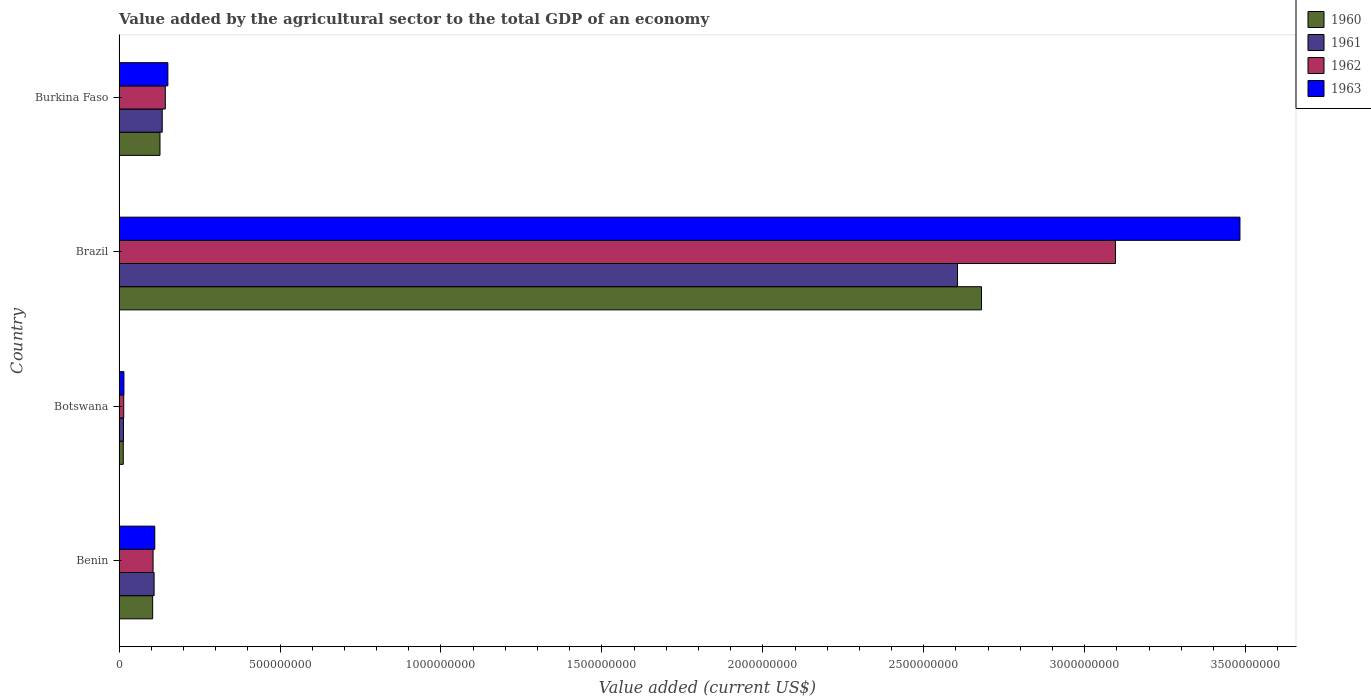How many groups of bars are there?
Your answer should be compact. 4. Are the number of bars per tick equal to the number of legend labels?
Provide a succinct answer. Yes. Are the number of bars on each tick of the Y-axis equal?
Your answer should be compact. Yes. What is the label of the 3rd group of bars from the top?
Your answer should be very brief. Botswana. What is the value added by the agricultural sector to the total GDP in 1960 in Burkina Faso?
Make the answer very short. 1.27e+08. Across all countries, what is the maximum value added by the agricultural sector to the total GDP in 1962?
Provide a succinct answer. 3.10e+09. Across all countries, what is the minimum value added by the agricultural sector to the total GDP in 1960?
Your answer should be compact. 1.31e+07. In which country was the value added by the agricultural sector to the total GDP in 1962 maximum?
Provide a succinct answer. Brazil. In which country was the value added by the agricultural sector to the total GDP in 1960 minimum?
Offer a terse response. Botswana. What is the total value added by the agricultural sector to the total GDP in 1960 in the graph?
Provide a short and direct response. 2.92e+09. What is the difference between the value added by the agricultural sector to the total GDP in 1962 in Brazil and that in Burkina Faso?
Keep it short and to the point. 2.95e+09. What is the difference between the value added by the agricultural sector to the total GDP in 1962 in Botswana and the value added by the agricultural sector to the total GDP in 1963 in Benin?
Keep it short and to the point. -9.65e+07. What is the average value added by the agricultural sector to the total GDP in 1962 per country?
Provide a short and direct response. 8.40e+08. What is the difference between the value added by the agricultural sector to the total GDP in 1962 and value added by the agricultural sector to the total GDP in 1960 in Burkina Faso?
Make the answer very short. 1.65e+07. What is the ratio of the value added by the agricultural sector to the total GDP in 1962 in Benin to that in Botswana?
Your answer should be compact. 7.29. Is the value added by the agricultural sector to the total GDP in 1962 in Botswana less than that in Burkina Faso?
Provide a short and direct response. Yes. Is the difference between the value added by the agricultural sector to the total GDP in 1962 in Brazil and Burkina Faso greater than the difference between the value added by the agricultural sector to the total GDP in 1960 in Brazil and Burkina Faso?
Your answer should be compact. Yes. What is the difference between the highest and the second highest value added by the agricultural sector to the total GDP in 1962?
Offer a terse response. 2.95e+09. What is the difference between the highest and the lowest value added by the agricultural sector to the total GDP in 1963?
Your response must be concise. 3.47e+09. Is the sum of the value added by the agricultural sector to the total GDP in 1962 in Botswana and Burkina Faso greater than the maximum value added by the agricultural sector to the total GDP in 1963 across all countries?
Offer a terse response. No. Are the values on the major ticks of X-axis written in scientific E-notation?
Ensure brevity in your answer.  No. Where does the legend appear in the graph?
Your response must be concise. Top right. How many legend labels are there?
Give a very brief answer. 4. What is the title of the graph?
Provide a succinct answer. Value added by the agricultural sector to the total GDP of an economy. What is the label or title of the X-axis?
Offer a very short reply. Value added (current US$). What is the Value added (current US$) in 1960 in Benin?
Offer a very short reply. 1.04e+08. What is the Value added (current US$) in 1961 in Benin?
Give a very brief answer. 1.09e+08. What is the Value added (current US$) of 1962 in Benin?
Make the answer very short. 1.06e+08. What is the Value added (current US$) in 1963 in Benin?
Make the answer very short. 1.11e+08. What is the Value added (current US$) of 1960 in Botswana?
Ensure brevity in your answer.  1.31e+07. What is the Value added (current US$) in 1961 in Botswana?
Keep it short and to the point. 1.38e+07. What is the Value added (current US$) of 1962 in Botswana?
Your answer should be very brief. 1.45e+07. What is the Value added (current US$) in 1963 in Botswana?
Your response must be concise. 1.51e+07. What is the Value added (current US$) of 1960 in Brazil?
Offer a terse response. 2.68e+09. What is the Value added (current US$) of 1961 in Brazil?
Offer a terse response. 2.60e+09. What is the Value added (current US$) in 1962 in Brazil?
Provide a short and direct response. 3.10e+09. What is the Value added (current US$) in 1963 in Brazil?
Offer a terse response. 3.48e+09. What is the Value added (current US$) in 1960 in Burkina Faso?
Your answer should be compact. 1.27e+08. What is the Value added (current US$) in 1961 in Burkina Faso?
Offer a very short reply. 1.34e+08. What is the Value added (current US$) in 1962 in Burkina Faso?
Ensure brevity in your answer.  1.44e+08. What is the Value added (current US$) in 1963 in Burkina Faso?
Keep it short and to the point. 1.52e+08. Across all countries, what is the maximum Value added (current US$) of 1960?
Give a very brief answer. 2.68e+09. Across all countries, what is the maximum Value added (current US$) of 1961?
Provide a short and direct response. 2.60e+09. Across all countries, what is the maximum Value added (current US$) of 1962?
Your answer should be compact. 3.10e+09. Across all countries, what is the maximum Value added (current US$) of 1963?
Give a very brief answer. 3.48e+09. Across all countries, what is the minimum Value added (current US$) of 1960?
Offer a terse response. 1.31e+07. Across all countries, what is the minimum Value added (current US$) of 1961?
Give a very brief answer. 1.38e+07. Across all countries, what is the minimum Value added (current US$) of 1962?
Provide a short and direct response. 1.45e+07. Across all countries, what is the minimum Value added (current US$) of 1963?
Offer a very short reply. 1.51e+07. What is the total Value added (current US$) in 1960 in the graph?
Provide a short and direct response. 2.92e+09. What is the total Value added (current US$) in 1961 in the graph?
Offer a very short reply. 2.86e+09. What is the total Value added (current US$) in 1962 in the graph?
Keep it short and to the point. 3.36e+09. What is the total Value added (current US$) in 1963 in the graph?
Your answer should be compact. 3.76e+09. What is the difference between the Value added (current US$) in 1960 in Benin and that in Botswana?
Keep it short and to the point. 9.13e+07. What is the difference between the Value added (current US$) of 1961 in Benin and that in Botswana?
Keep it short and to the point. 9.51e+07. What is the difference between the Value added (current US$) in 1962 in Benin and that in Botswana?
Give a very brief answer. 9.12e+07. What is the difference between the Value added (current US$) of 1963 in Benin and that in Botswana?
Keep it short and to the point. 9.59e+07. What is the difference between the Value added (current US$) of 1960 in Benin and that in Brazil?
Provide a succinct answer. -2.57e+09. What is the difference between the Value added (current US$) of 1961 in Benin and that in Brazil?
Give a very brief answer. -2.50e+09. What is the difference between the Value added (current US$) of 1962 in Benin and that in Brazil?
Your answer should be compact. -2.99e+09. What is the difference between the Value added (current US$) of 1963 in Benin and that in Brazil?
Give a very brief answer. -3.37e+09. What is the difference between the Value added (current US$) in 1960 in Benin and that in Burkina Faso?
Provide a short and direct response. -2.28e+07. What is the difference between the Value added (current US$) of 1961 in Benin and that in Burkina Faso?
Provide a succinct answer. -2.53e+07. What is the difference between the Value added (current US$) in 1962 in Benin and that in Burkina Faso?
Provide a succinct answer. -3.80e+07. What is the difference between the Value added (current US$) of 1963 in Benin and that in Burkina Faso?
Provide a short and direct response. -4.07e+07. What is the difference between the Value added (current US$) of 1960 in Botswana and that in Brazil?
Give a very brief answer. -2.67e+09. What is the difference between the Value added (current US$) in 1961 in Botswana and that in Brazil?
Keep it short and to the point. -2.59e+09. What is the difference between the Value added (current US$) of 1962 in Botswana and that in Brazil?
Your answer should be compact. -3.08e+09. What is the difference between the Value added (current US$) of 1963 in Botswana and that in Brazil?
Provide a succinct answer. -3.47e+09. What is the difference between the Value added (current US$) in 1960 in Botswana and that in Burkina Faso?
Give a very brief answer. -1.14e+08. What is the difference between the Value added (current US$) of 1961 in Botswana and that in Burkina Faso?
Ensure brevity in your answer.  -1.20e+08. What is the difference between the Value added (current US$) of 1962 in Botswana and that in Burkina Faso?
Ensure brevity in your answer.  -1.29e+08. What is the difference between the Value added (current US$) in 1963 in Botswana and that in Burkina Faso?
Offer a terse response. -1.37e+08. What is the difference between the Value added (current US$) in 1960 in Brazil and that in Burkina Faso?
Give a very brief answer. 2.55e+09. What is the difference between the Value added (current US$) of 1961 in Brazil and that in Burkina Faso?
Offer a terse response. 2.47e+09. What is the difference between the Value added (current US$) in 1962 in Brazil and that in Burkina Faso?
Make the answer very short. 2.95e+09. What is the difference between the Value added (current US$) of 1963 in Brazil and that in Burkina Faso?
Keep it short and to the point. 3.33e+09. What is the difference between the Value added (current US$) in 1960 in Benin and the Value added (current US$) in 1961 in Botswana?
Make the answer very short. 9.06e+07. What is the difference between the Value added (current US$) in 1960 in Benin and the Value added (current US$) in 1962 in Botswana?
Your response must be concise. 8.99e+07. What is the difference between the Value added (current US$) of 1960 in Benin and the Value added (current US$) of 1963 in Botswana?
Make the answer very short. 8.93e+07. What is the difference between the Value added (current US$) of 1961 in Benin and the Value added (current US$) of 1962 in Botswana?
Make the answer very short. 9.44e+07. What is the difference between the Value added (current US$) of 1961 in Benin and the Value added (current US$) of 1963 in Botswana?
Provide a succinct answer. 9.37e+07. What is the difference between the Value added (current US$) in 1962 in Benin and the Value added (current US$) in 1963 in Botswana?
Provide a succinct answer. 9.06e+07. What is the difference between the Value added (current US$) of 1960 in Benin and the Value added (current US$) of 1961 in Brazil?
Provide a succinct answer. -2.50e+09. What is the difference between the Value added (current US$) of 1960 in Benin and the Value added (current US$) of 1962 in Brazil?
Offer a terse response. -2.99e+09. What is the difference between the Value added (current US$) in 1960 in Benin and the Value added (current US$) in 1963 in Brazil?
Offer a terse response. -3.38e+09. What is the difference between the Value added (current US$) in 1961 in Benin and the Value added (current US$) in 1962 in Brazil?
Your answer should be compact. -2.99e+09. What is the difference between the Value added (current US$) of 1961 in Benin and the Value added (current US$) of 1963 in Brazil?
Offer a very short reply. -3.37e+09. What is the difference between the Value added (current US$) of 1962 in Benin and the Value added (current US$) of 1963 in Brazil?
Keep it short and to the point. -3.38e+09. What is the difference between the Value added (current US$) in 1960 in Benin and the Value added (current US$) in 1961 in Burkina Faso?
Your answer should be compact. -2.98e+07. What is the difference between the Value added (current US$) in 1960 in Benin and the Value added (current US$) in 1962 in Burkina Faso?
Keep it short and to the point. -3.93e+07. What is the difference between the Value added (current US$) in 1960 in Benin and the Value added (current US$) in 1963 in Burkina Faso?
Give a very brief answer. -4.73e+07. What is the difference between the Value added (current US$) of 1961 in Benin and the Value added (current US$) of 1962 in Burkina Faso?
Provide a short and direct response. -3.48e+07. What is the difference between the Value added (current US$) in 1961 in Benin and the Value added (current US$) in 1963 in Burkina Faso?
Your answer should be compact. -4.28e+07. What is the difference between the Value added (current US$) in 1962 in Benin and the Value added (current US$) in 1963 in Burkina Faso?
Ensure brevity in your answer.  -4.60e+07. What is the difference between the Value added (current US$) in 1960 in Botswana and the Value added (current US$) in 1961 in Brazil?
Keep it short and to the point. -2.59e+09. What is the difference between the Value added (current US$) of 1960 in Botswana and the Value added (current US$) of 1962 in Brazil?
Your answer should be very brief. -3.08e+09. What is the difference between the Value added (current US$) in 1960 in Botswana and the Value added (current US$) in 1963 in Brazil?
Provide a short and direct response. -3.47e+09. What is the difference between the Value added (current US$) of 1961 in Botswana and the Value added (current US$) of 1962 in Brazil?
Give a very brief answer. -3.08e+09. What is the difference between the Value added (current US$) in 1961 in Botswana and the Value added (current US$) in 1963 in Brazil?
Ensure brevity in your answer.  -3.47e+09. What is the difference between the Value added (current US$) in 1962 in Botswana and the Value added (current US$) in 1963 in Brazil?
Your answer should be compact. -3.47e+09. What is the difference between the Value added (current US$) in 1960 in Botswana and the Value added (current US$) in 1961 in Burkina Faso?
Your answer should be compact. -1.21e+08. What is the difference between the Value added (current US$) in 1960 in Botswana and the Value added (current US$) in 1962 in Burkina Faso?
Provide a short and direct response. -1.31e+08. What is the difference between the Value added (current US$) of 1960 in Botswana and the Value added (current US$) of 1963 in Burkina Faso?
Your response must be concise. -1.39e+08. What is the difference between the Value added (current US$) in 1961 in Botswana and the Value added (current US$) in 1962 in Burkina Faso?
Offer a terse response. -1.30e+08. What is the difference between the Value added (current US$) in 1961 in Botswana and the Value added (current US$) in 1963 in Burkina Faso?
Provide a short and direct response. -1.38e+08. What is the difference between the Value added (current US$) of 1962 in Botswana and the Value added (current US$) of 1963 in Burkina Faso?
Your answer should be compact. -1.37e+08. What is the difference between the Value added (current US$) of 1960 in Brazil and the Value added (current US$) of 1961 in Burkina Faso?
Your answer should be very brief. 2.55e+09. What is the difference between the Value added (current US$) of 1960 in Brazil and the Value added (current US$) of 1962 in Burkina Faso?
Your response must be concise. 2.54e+09. What is the difference between the Value added (current US$) in 1960 in Brazil and the Value added (current US$) in 1963 in Burkina Faso?
Make the answer very short. 2.53e+09. What is the difference between the Value added (current US$) of 1961 in Brazil and the Value added (current US$) of 1962 in Burkina Faso?
Offer a terse response. 2.46e+09. What is the difference between the Value added (current US$) of 1961 in Brazil and the Value added (current US$) of 1963 in Burkina Faso?
Offer a very short reply. 2.45e+09. What is the difference between the Value added (current US$) of 1962 in Brazil and the Value added (current US$) of 1963 in Burkina Faso?
Your answer should be very brief. 2.94e+09. What is the average Value added (current US$) in 1960 per country?
Your response must be concise. 7.31e+08. What is the average Value added (current US$) of 1961 per country?
Your answer should be very brief. 7.15e+08. What is the average Value added (current US$) of 1962 per country?
Offer a terse response. 8.40e+08. What is the average Value added (current US$) of 1963 per country?
Provide a short and direct response. 9.40e+08. What is the difference between the Value added (current US$) in 1960 and Value added (current US$) in 1961 in Benin?
Offer a terse response. -4.46e+06. What is the difference between the Value added (current US$) in 1960 and Value added (current US$) in 1962 in Benin?
Your response must be concise. -1.30e+06. What is the difference between the Value added (current US$) in 1960 and Value added (current US$) in 1963 in Benin?
Provide a short and direct response. -6.61e+06. What is the difference between the Value added (current US$) in 1961 and Value added (current US$) in 1962 in Benin?
Make the answer very short. 3.16e+06. What is the difference between the Value added (current US$) of 1961 and Value added (current US$) of 1963 in Benin?
Keep it short and to the point. -2.15e+06. What is the difference between the Value added (current US$) in 1962 and Value added (current US$) in 1963 in Benin?
Your answer should be very brief. -5.30e+06. What is the difference between the Value added (current US$) in 1960 and Value added (current US$) in 1961 in Botswana?
Give a very brief answer. -6.50e+05. What is the difference between the Value added (current US$) in 1960 and Value added (current US$) in 1962 in Botswana?
Offer a terse response. -1.35e+06. What is the difference between the Value added (current US$) in 1960 and Value added (current US$) in 1963 in Botswana?
Make the answer very short. -1.99e+06. What is the difference between the Value added (current US$) of 1961 and Value added (current US$) of 1962 in Botswana?
Ensure brevity in your answer.  -7.04e+05. What is the difference between the Value added (current US$) in 1961 and Value added (current US$) in 1963 in Botswana?
Provide a succinct answer. -1.34e+06. What is the difference between the Value added (current US$) in 1962 and Value added (current US$) in 1963 in Botswana?
Your answer should be very brief. -6.34e+05. What is the difference between the Value added (current US$) of 1960 and Value added (current US$) of 1961 in Brazil?
Provide a succinct answer. 7.45e+07. What is the difference between the Value added (current US$) in 1960 and Value added (current US$) in 1962 in Brazil?
Offer a very short reply. -4.16e+08. What is the difference between the Value added (current US$) in 1960 and Value added (current US$) in 1963 in Brazil?
Provide a succinct answer. -8.03e+08. What is the difference between the Value added (current US$) of 1961 and Value added (current US$) of 1962 in Brazil?
Your answer should be compact. -4.91e+08. What is the difference between the Value added (current US$) in 1961 and Value added (current US$) in 1963 in Brazil?
Offer a very short reply. -8.77e+08. What is the difference between the Value added (current US$) of 1962 and Value added (current US$) of 1963 in Brazil?
Offer a very short reply. -3.87e+08. What is the difference between the Value added (current US$) in 1960 and Value added (current US$) in 1961 in Burkina Faso?
Offer a terse response. -7.00e+06. What is the difference between the Value added (current US$) in 1960 and Value added (current US$) in 1962 in Burkina Faso?
Your answer should be very brief. -1.65e+07. What is the difference between the Value added (current US$) in 1960 and Value added (current US$) in 1963 in Burkina Faso?
Offer a very short reply. -2.45e+07. What is the difference between the Value added (current US$) in 1961 and Value added (current US$) in 1962 in Burkina Faso?
Provide a succinct answer. -9.53e+06. What is the difference between the Value added (current US$) in 1961 and Value added (current US$) in 1963 in Burkina Faso?
Give a very brief answer. -1.75e+07. What is the difference between the Value added (current US$) in 1962 and Value added (current US$) in 1963 in Burkina Faso?
Keep it short and to the point. -7.98e+06. What is the ratio of the Value added (current US$) in 1960 in Benin to that in Botswana?
Keep it short and to the point. 7.94. What is the ratio of the Value added (current US$) of 1961 in Benin to that in Botswana?
Offer a very short reply. 7.89. What is the ratio of the Value added (current US$) in 1962 in Benin to that in Botswana?
Keep it short and to the point. 7.29. What is the ratio of the Value added (current US$) in 1963 in Benin to that in Botswana?
Offer a very short reply. 7.34. What is the ratio of the Value added (current US$) of 1960 in Benin to that in Brazil?
Give a very brief answer. 0.04. What is the ratio of the Value added (current US$) of 1961 in Benin to that in Brazil?
Keep it short and to the point. 0.04. What is the ratio of the Value added (current US$) in 1962 in Benin to that in Brazil?
Your answer should be compact. 0.03. What is the ratio of the Value added (current US$) of 1963 in Benin to that in Brazil?
Give a very brief answer. 0.03. What is the ratio of the Value added (current US$) in 1960 in Benin to that in Burkina Faso?
Make the answer very short. 0.82. What is the ratio of the Value added (current US$) of 1961 in Benin to that in Burkina Faso?
Provide a succinct answer. 0.81. What is the ratio of the Value added (current US$) of 1962 in Benin to that in Burkina Faso?
Provide a succinct answer. 0.74. What is the ratio of the Value added (current US$) of 1963 in Benin to that in Burkina Faso?
Ensure brevity in your answer.  0.73. What is the ratio of the Value added (current US$) of 1960 in Botswana to that in Brazil?
Offer a very short reply. 0. What is the ratio of the Value added (current US$) in 1961 in Botswana to that in Brazil?
Your answer should be compact. 0.01. What is the ratio of the Value added (current US$) of 1962 in Botswana to that in Brazil?
Your answer should be compact. 0. What is the ratio of the Value added (current US$) in 1963 in Botswana to that in Brazil?
Make the answer very short. 0. What is the ratio of the Value added (current US$) of 1960 in Botswana to that in Burkina Faso?
Ensure brevity in your answer.  0.1. What is the ratio of the Value added (current US$) of 1961 in Botswana to that in Burkina Faso?
Your answer should be very brief. 0.1. What is the ratio of the Value added (current US$) of 1962 in Botswana to that in Burkina Faso?
Offer a terse response. 0.1. What is the ratio of the Value added (current US$) of 1963 in Botswana to that in Burkina Faso?
Your answer should be compact. 0.1. What is the ratio of the Value added (current US$) in 1960 in Brazil to that in Burkina Faso?
Your response must be concise. 21.07. What is the ratio of the Value added (current US$) of 1961 in Brazil to that in Burkina Faso?
Provide a succinct answer. 19.41. What is the ratio of the Value added (current US$) of 1962 in Brazil to that in Burkina Faso?
Make the answer very short. 21.54. What is the ratio of the Value added (current US$) of 1963 in Brazil to that in Burkina Faso?
Provide a succinct answer. 22.96. What is the difference between the highest and the second highest Value added (current US$) in 1960?
Offer a very short reply. 2.55e+09. What is the difference between the highest and the second highest Value added (current US$) of 1961?
Make the answer very short. 2.47e+09. What is the difference between the highest and the second highest Value added (current US$) of 1962?
Your answer should be compact. 2.95e+09. What is the difference between the highest and the second highest Value added (current US$) in 1963?
Provide a short and direct response. 3.33e+09. What is the difference between the highest and the lowest Value added (current US$) of 1960?
Offer a terse response. 2.67e+09. What is the difference between the highest and the lowest Value added (current US$) in 1961?
Offer a very short reply. 2.59e+09. What is the difference between the highest and the lowest Value added (current US$) of 1962?
Provide a short and direct response. 3.08e+09. What is the difference between the highest and the lowest Value added (current US$) of 1963?
Give a very brief answer. 3.47e+09. 